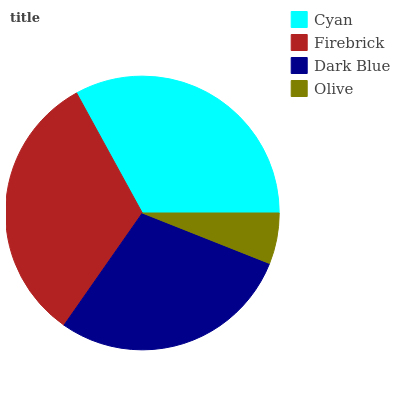Is Olive the minimum?
Answer yes or no. Yes. Is Cyan the maximum?
Answer yes or no. Yes. Is Firebrick the minimum?
Answer yes or no. No. Is Firebrick the maximum?
Answer yes or no. No. Is Cyan greater than Firebrick?
Answer yes or no. Yes. Is Firebrick less than Cyan?
Answer yes or no. Yes. Is Firebrick greater than Cyan?
Answer yes or no. No. Is Cyan less than Firebrick?
Answer yes or no. No. Is Firebrick the high median?
Answer yes or no. Yes. Is Dark Blue the low median?
Answer yes or no. Yes. Is Olive the high median?
Answer yes or no. No. Is Cyan the low median?
Answer yes or no. No. 